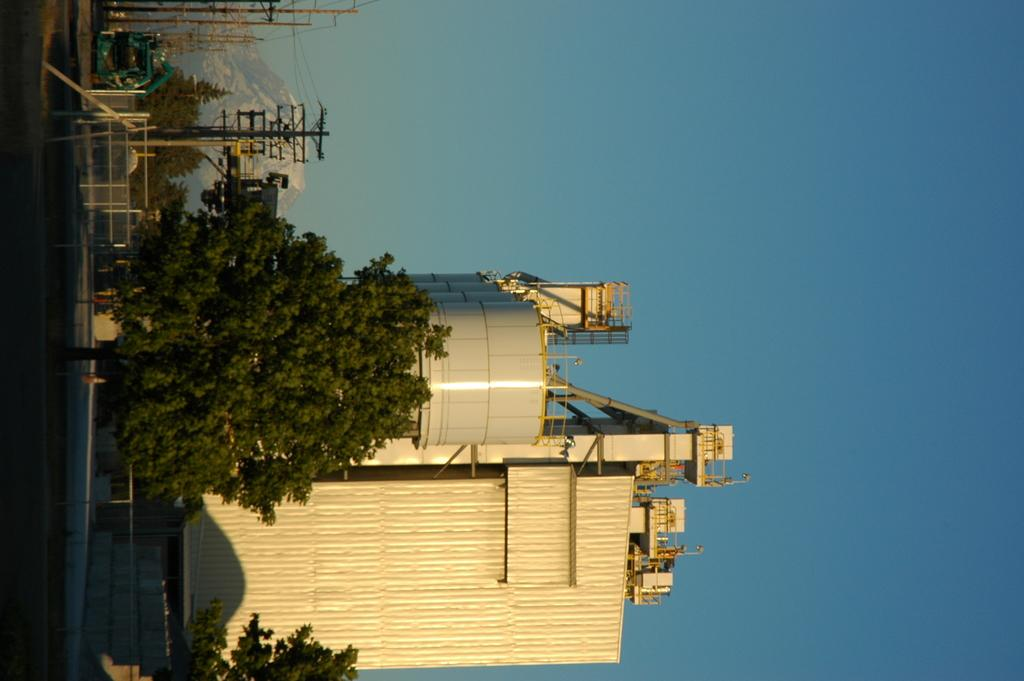What type of structure is visible in the image? There is a factory in the image. What other objects can be seen in the image? There are electrical poles and trees visible in the image. What type of pathway is present in the image? There is a road in the image. What is the color of the sky in the image? The sky is blue in the image. What type of property is being sold in the image? There is no property being sold in the image; it features a factory, electrical poles, trees, a road, and a blue sky. What type of feast is being prepared in the image? There is no feast being prepared in the image; it features a factory, electrical poles, trees, a road, and a blue sky. 